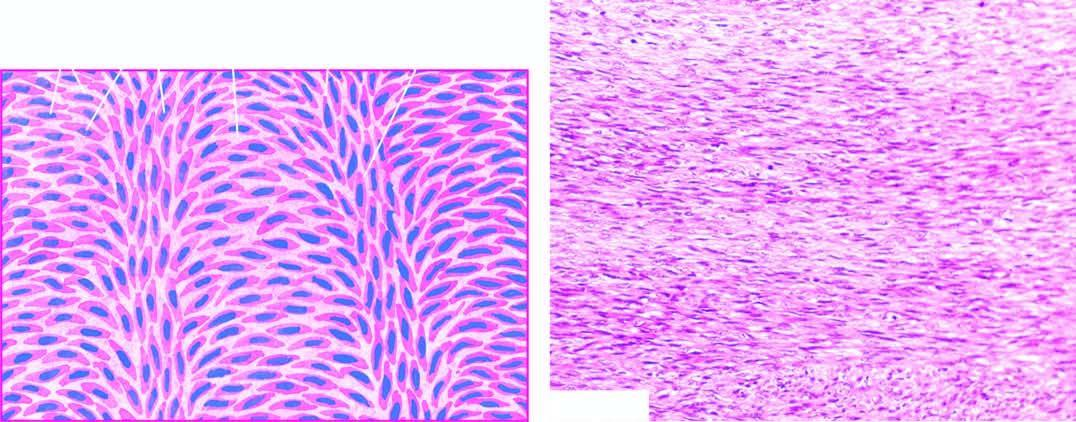re a few mitotic figures also seen?
Answer the question using a single word or phrase. Yes 